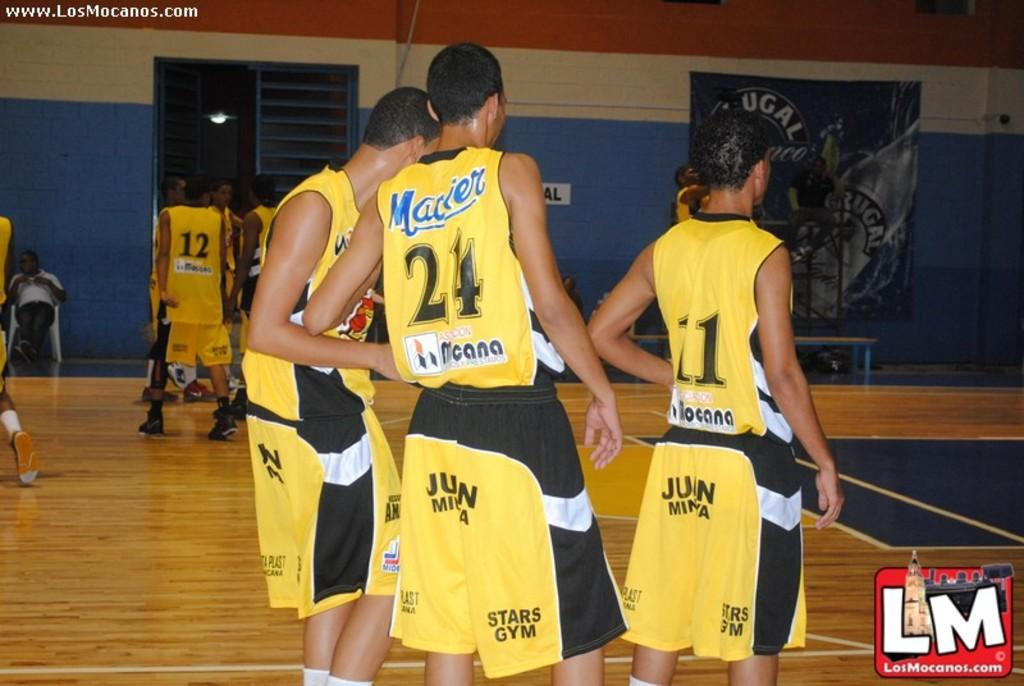<image>
Offer a succinct explanation of the picture presented. LM basketball players wearing yellow Star Gym uniforms 